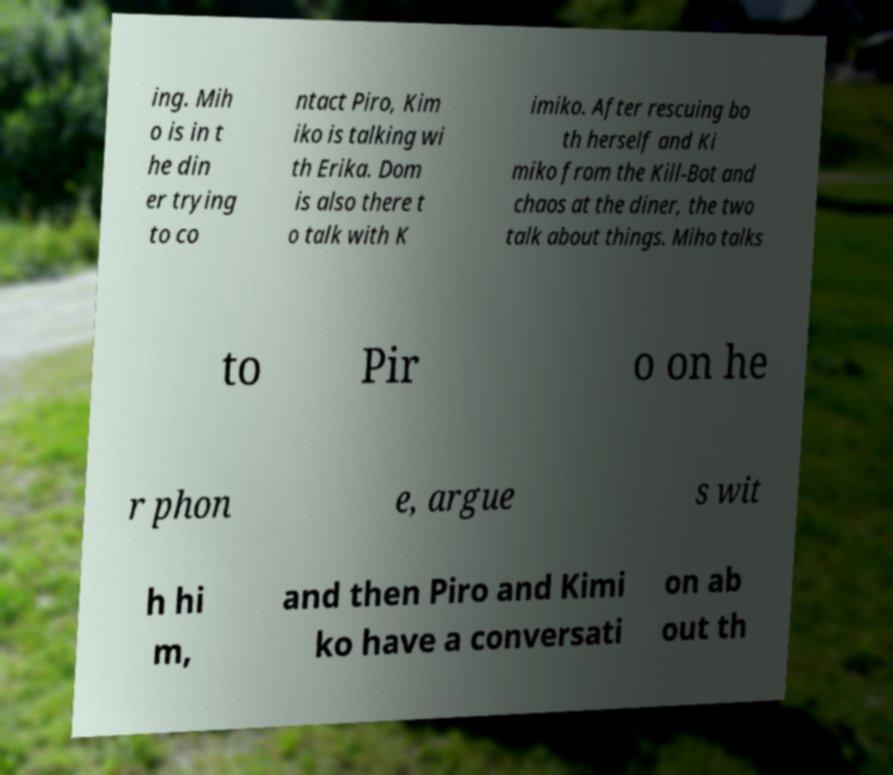What messages or text are displayed in this image? I need them in a readable, typed format. ing. Mih o is in t he din er trying to co ntact Piro, Kim iko is talking wi th Erika. Dom is also there t o talk with K imiko. After rescuing bo th herself and Ki miko from the Kill-Bot and chaos at the diner, the two talk about things. Miho talks to Pir o on he r phon e, argue s wit h hi m, and then Piro and Kimi ko have a conversati on ab out th 